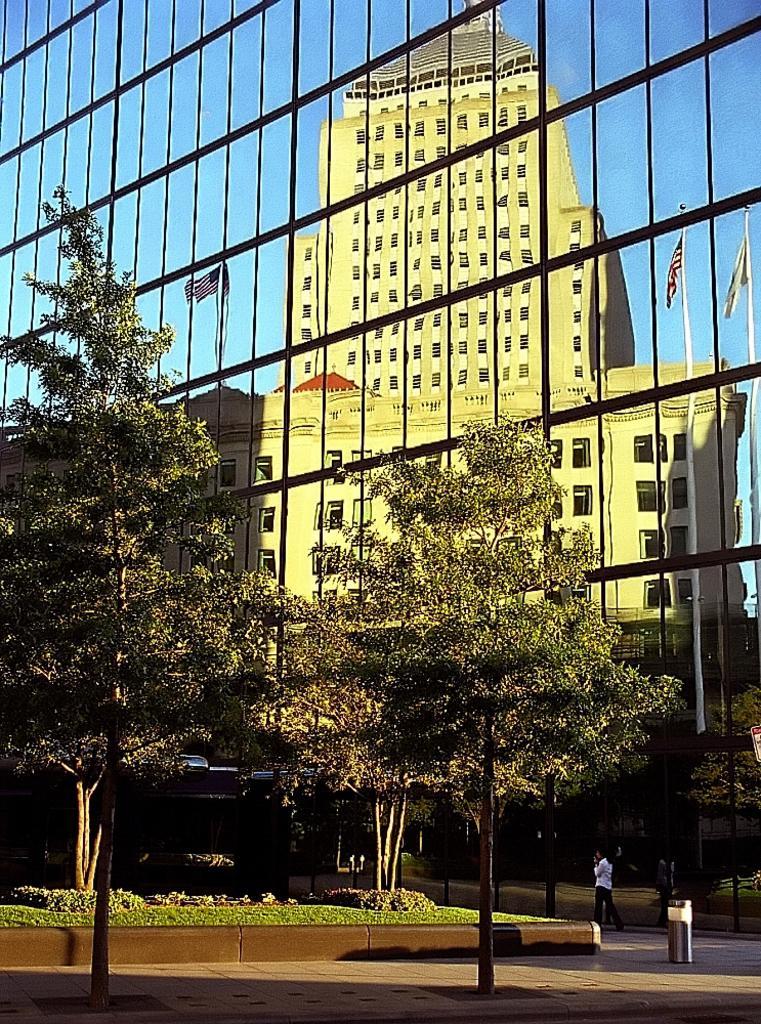In one or two sentences, can you explain what this image depicts? In this image we can see a building, flags, flag posts, trees, persons on the road, bins, bushes, plants and sky. 